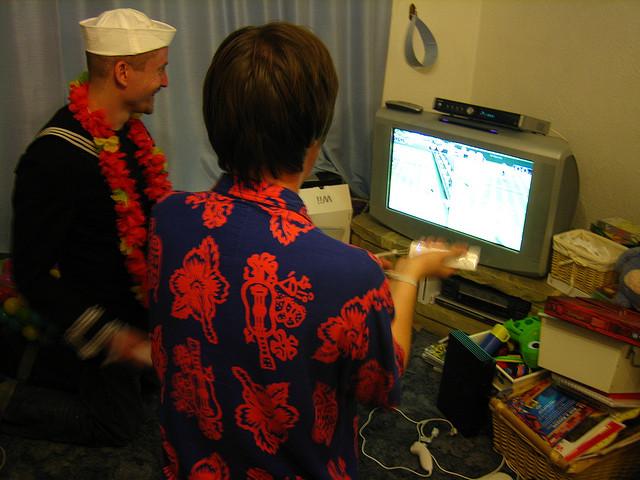What is he wearing?
Answer briefly. Shirt. What is the person holding?
Keep it brief. Wii remote. What is the boy doing?
Write a very short answer. Playing wii. How many people are looking at the computer?
Short answer required. 2. Does the person have long or short hair?
Write a very short answer. Short. How many color on her shirt?
Write a very short answer. 2. What color are the drapes?
Keep it brief. Blue. Are they likely in America?
Short answer required. Yes. What is this person dressed as?
Write a very short answer. Sailor. Is it daytime?
Write a very short answer. No. What is the man wearing on his head?
Write a very short answer. Hat. 